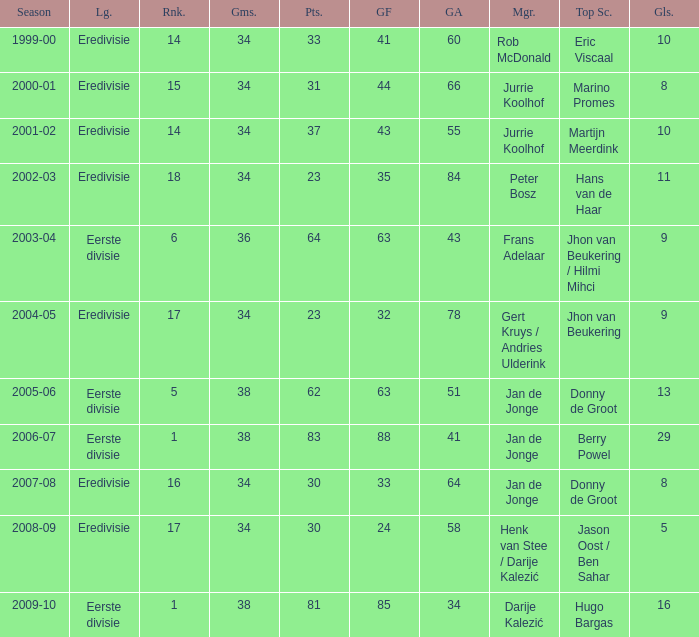What is the rank of manager Rob Mcdonald? 1.0. 